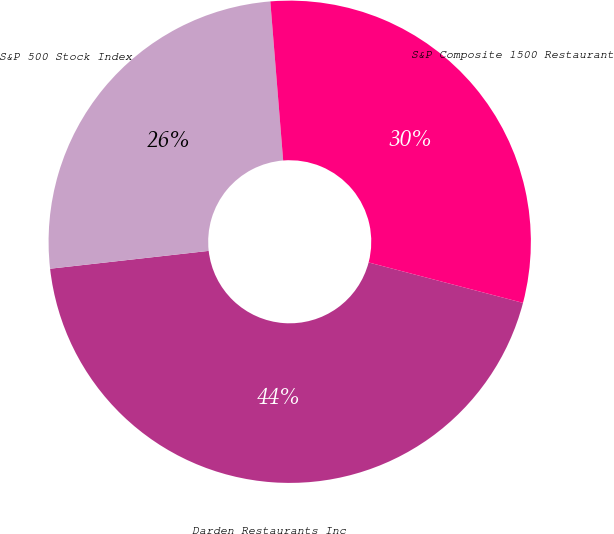Convert chart to OTSL. <chart><loc_0><loc_0><loc_500><loc_500><pie_chart><fcel>Darden Restaurants Inc<fcel>S&P 500 Stock Index<fcel>S&P Composite 1500 Restaurant<nl><fcel>44.14%<fcel>25.5%<fcel>30.36%<nl></chart> 